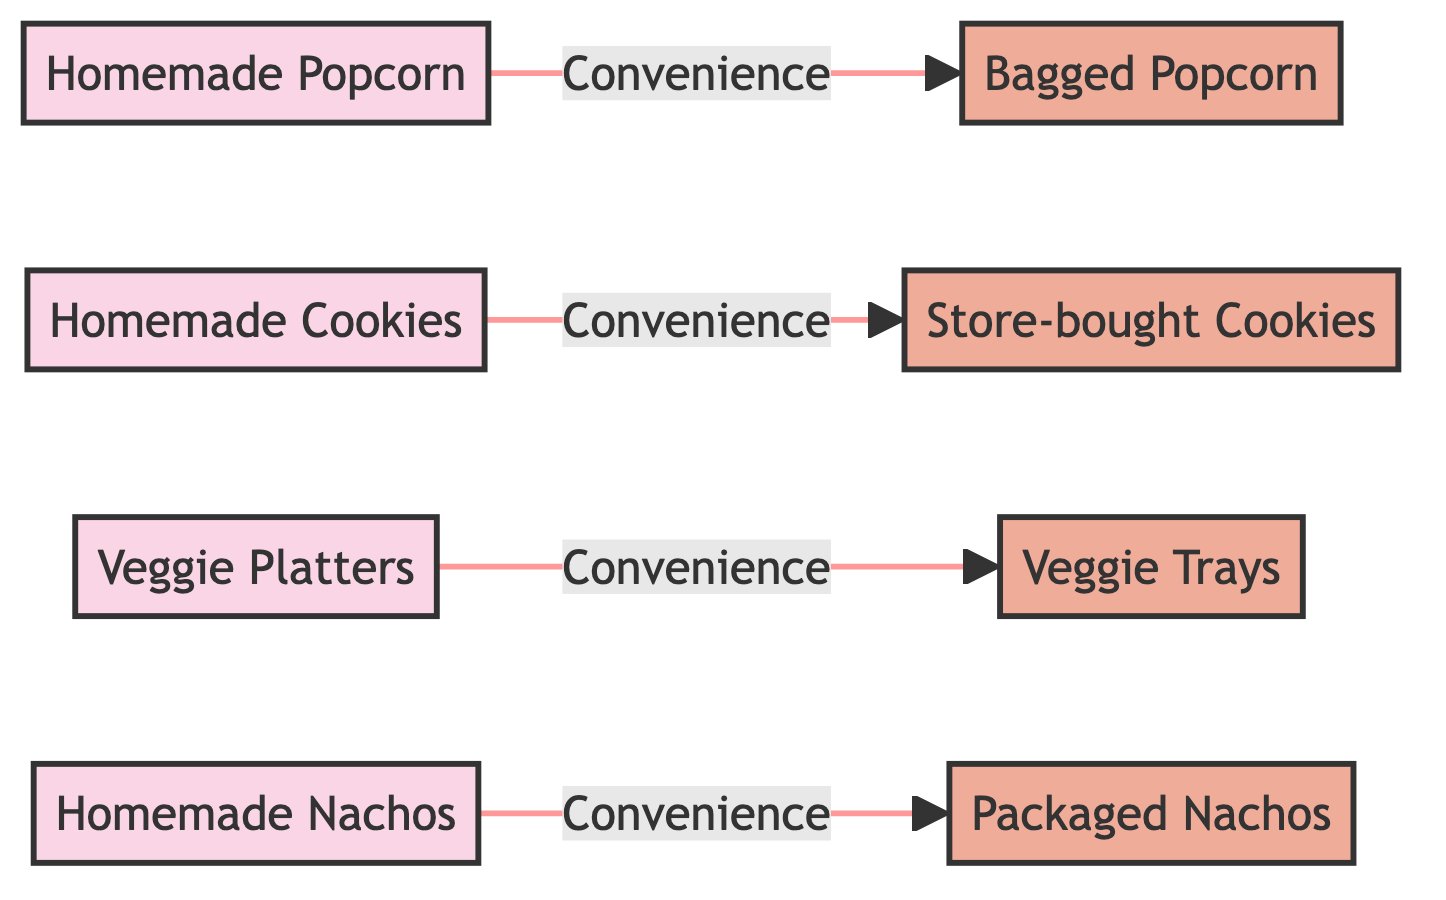What's the total number of snack types shown in the diagram? The diagram lists four homemade snack types and four store-bought snack types, so the total is 4 + 4 = 8 snack types.
Answer: 8 Which snack is related to homemade nachos? Homemade nachos connect to packaged nachos through the convenience relationship indicated by the arrow leading to it.
Answer: Packaged nachos How many homemade snacks are there in total? By counting the nodes in the homemade category, there are four types: homemade popcorn, homemade cookies, veggie platters, and homemade nachos.
Answer: 4 What is the relationship labeled between homemade cookies and store-bought cookies? The arrow coming from homemade cookies to store-bought cookies is labeled with "Convenience," indicating the transition from homemade to store-bought options for cookies.
Answer: Convenience Which store-bought snack corresponds to veggie platters? Veggie platters are connected to veggie trays, showing the transition from homemade to convenience versions of veggie snacks, indicated by the arrow.
Answer: Veggie trays What type of snack do all store-bought options share? Each store-bought snack type derives from its homemade version based on the convenience aspect, showing a common characteristic among them.
Answer: Convenience How many arrows are present in the diagram? The diagram has four arrows connecting each homemade snack type to its respective store-bought alternative, leading to a total of 4 arrows.
Answer: 4 Which homemade snack does not have a corresponding store-bought alternative? Each homemade snack listed has a corresponding store-bought alternative, indicating that all homemade snacks can transition to convenience snacks. Thus, there are no homemade snacks without a counterpart.
Answer: None What do the colors represent in the diagram? The colors are distinctively assigned to categorize snack types, where the pink shade represents homemade snacks and the orange-colored shade represents store-bought snacks.
Answer: Snack type categories 